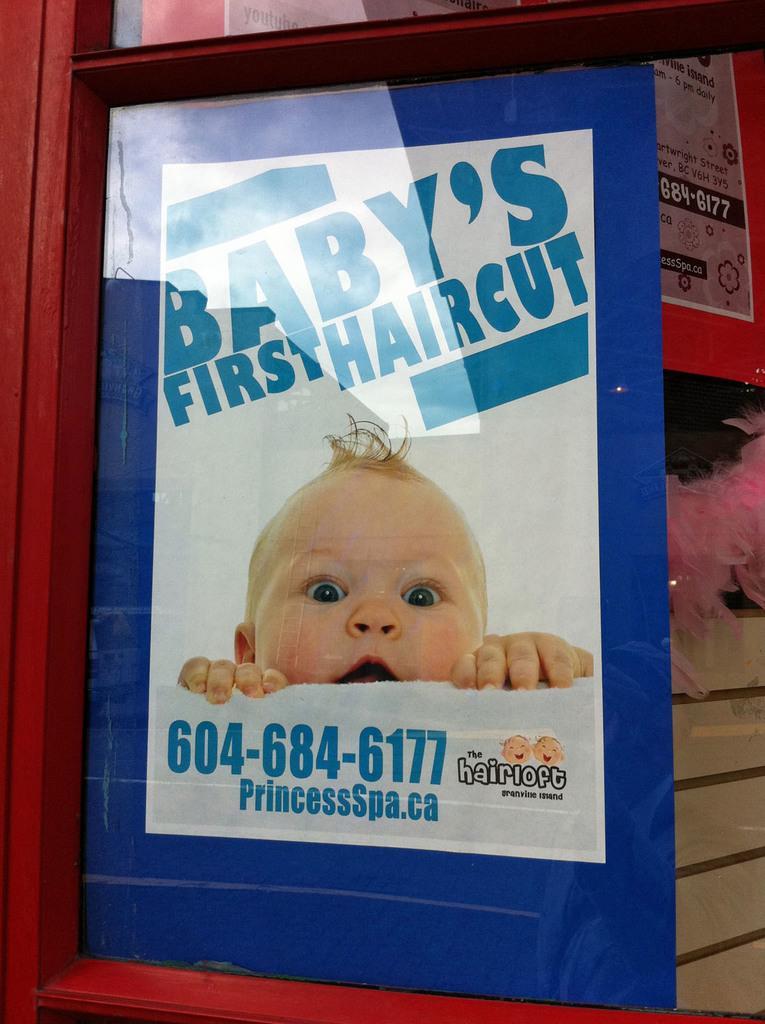Can you describe this image briefly? This picture might be taken from outside of the glass door. In this image, we can see a glass door, inside the glass door, we can also see a poster, on the poster, we can see a kid, inside the glass door, we can also see some hoardings. 